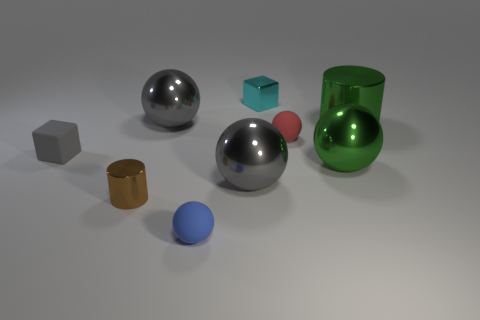There is a small ball behind the shiny cylinder that is to the left of the cyan shiny thing; is there a shiny cylinder that is behind it? Indeed, there is a shiny cylinder positioned behind the small ball, which is itself situated behind the metallic cylinder to the left of the cyan colored cube. 